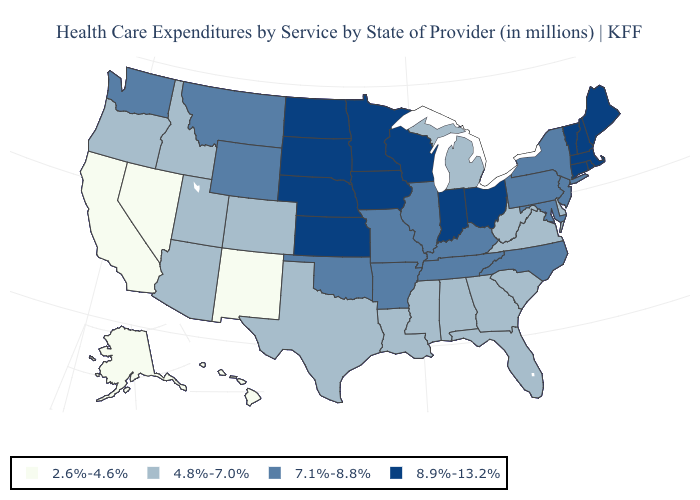Does Vermont have the same value as Arkansas?
Quick response, please. No. What is the highest value in the West ?
Write a very short answer. 7.1%-8.8%. Name the states that have a value in the range 2.6%-4.6%?
Quick response, please. Alaska, California, Hawaii, Nevada, New Mexico. What is the value of West Virginia?
Concise answer only. 4.8%-7.0%. Does West Virginia have the lowest value in the USA?
Be succinct. No. Name the states that have a value in the range 8.9%-13.2%?
Write a very short answer. Connecticut, Indiana, Iowa, Kansas, Maine, Massachusetts, Minnesota, Nebraska, New Hampshire, North Dakota, Ohio, Rhode Island, South Dakota, Vermont, Wisconsin. What is the lowest value in the USA?
Quick response, please. 2.6%-4.6%. Name the states that have a value in the range 7.1%-8.8%?
Give a very brief answer. Arkansas, Illinois, Kentucky, Maryland, Missouri, Montana, New Jersey, New York, North Carolina, Oklahoma, Pennsylvania, Tennessee, Washington, Wyoming. What is the value of New Jersey?
Keep it brief. 7.1%-8.8%. Does South Carolina have the highest value in the USA?
Keep it brief. No. Among the states that border New York , which have the lowest value?
Answer briefly. New Jersey, Pennsylvania. Does the first symbol in the legend represent the smallest category?
Write a very short answer. Yes. Name the states that have a value in the range 2.6%-4.6%?
Answer briefly. Alaska, California, Hawaii, Nevada, New Mexico. Does the map have missing data?
Concise answer only. No. Among the states that border South Dakota , which have the highest value?
Keep it brief. Iowa, Minnesota, Nebraska, North Dakota. 